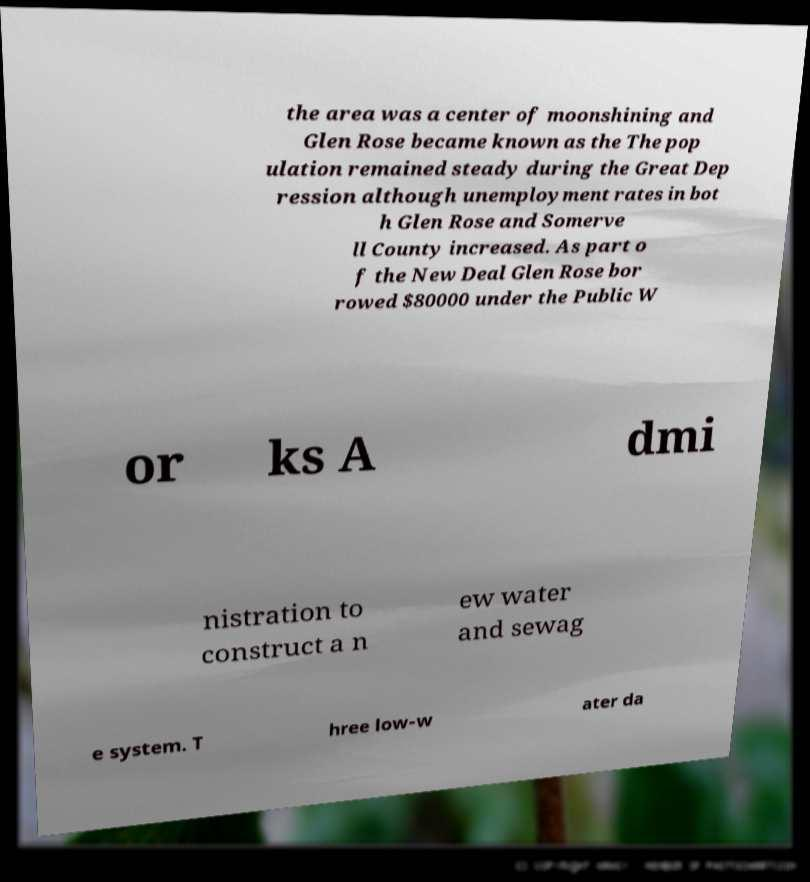I need the written content from this picture converted into text. Can you do that? the area was a center of moonshining and Glen Rose became known as the The pop ulation remained steady during the Great Dep ression although unemployment rates in bot h Glen Rose and Somerve ll County increased. As part o f the New Deal Glen Rose bor rowed $80000 under the Public W or ks A dmi nistration to construct a n ew water and sewag e system. T hree low-w ater da 